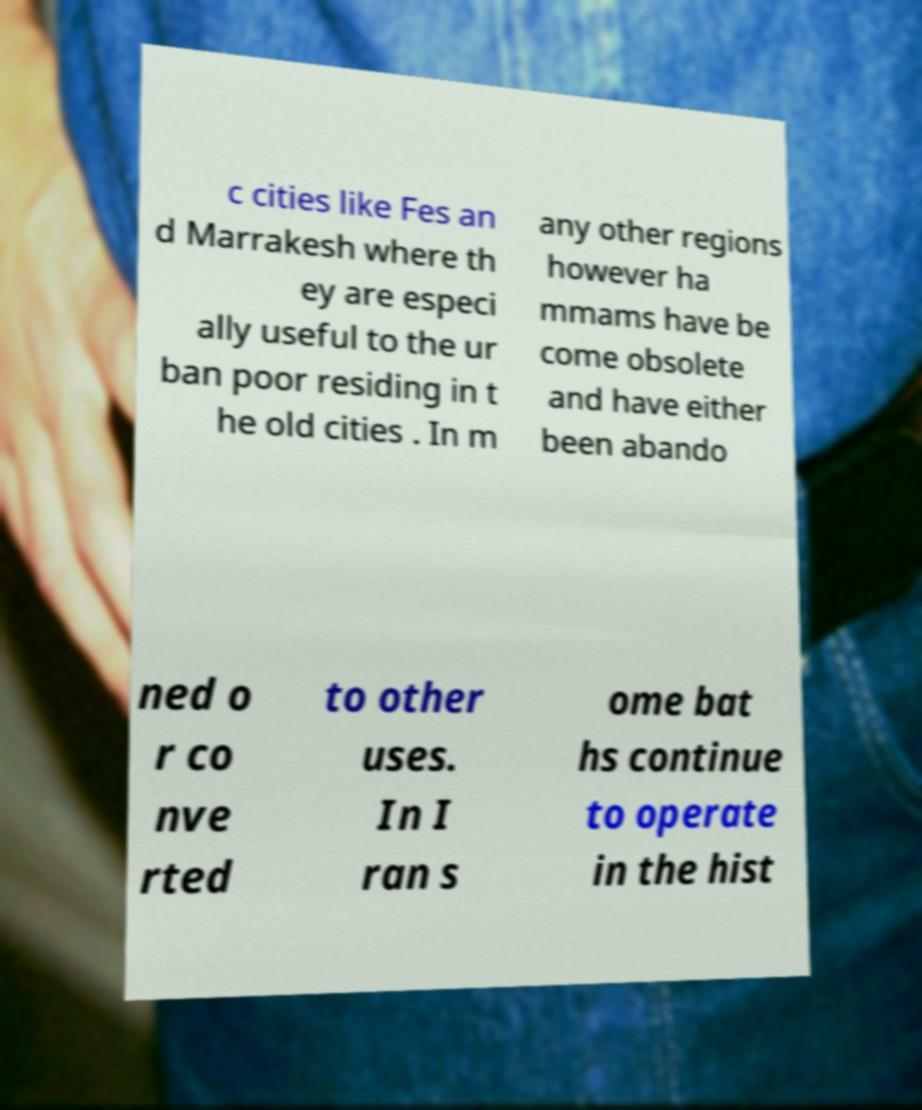What messages or text are displayed in this image? I need them in a readable, typed format. c cities like Fes an d Marrakesh where th ey are especi ally useful to the ur ban poor residing in t he old cities . In m any other regions however ha mmams have be come obsolete and have either been abando ned o r co nve rted to other uses. In I ran s ome bat hs continue to operate in the hist 